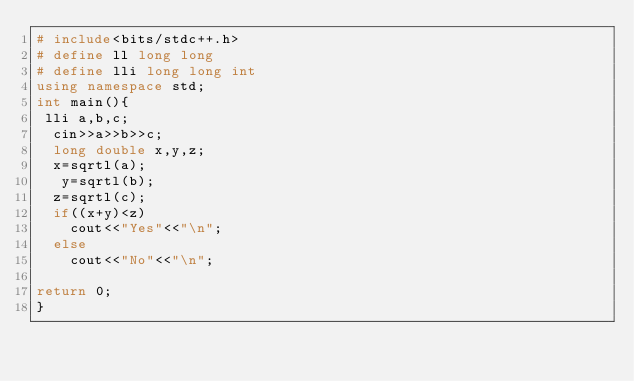Convert code to text. <code><loc_0><loc_0><loc_500><loc_500><_C++_># include<bits/stdc++.h>
# define ll long long
# define lli long long int
using namespace std;
int main(){
 lli a,b,c;
  cin>>a>>b>>c;
  long double x,y,z;
  x=sqrtl(a);
   y=sqrtl(b);
  z=sqrtl(c);
  if((x+y)<z)
    cout<<"Yes"<<"\n";
  else
    cout<<"No"<<"\n";
  
return 0;
}</code> 